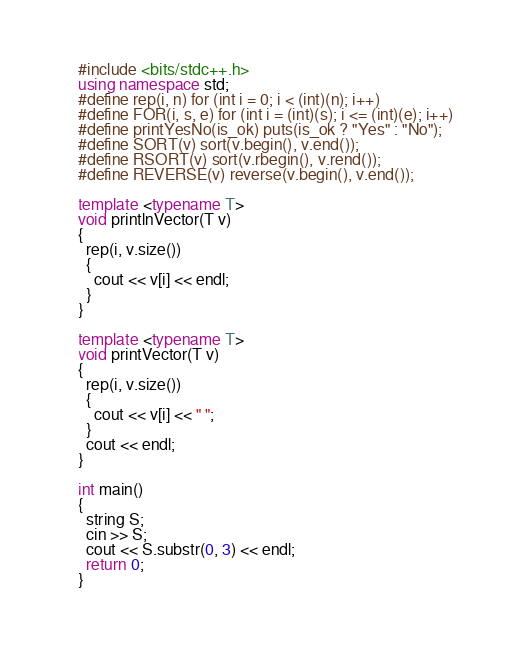Convert code to text. <code><loc_0><loc_0><loc_500><loc_500><_C++_>#include <bits/stdc++.h>
using namespace std;
#define rep(i, n) for (int i = 0; i < (int)(n); i++)
#define FOR(i, s, e) for (int i = (int)(s); i <= (int)(e); i++)
#define printYesNo(is_ok) puts(is_ok ? "Yes" : "No");
#define SORT(v) sort(v.begin(), v.end());
#define RSORT(v) sort(v.rbegin(), v.rend());
#define REVERSE(v) reverse(v.begin(), v.end());

template <typename T>
void printlnVector(T v)
{
  rep(i, v.size())
  {
    cout << v[i] << endl;
  }
}

template <typename T>
void printVector(T v)
{
  rep(i, v.size())
  {
    cout << v[i] << " ";
  }
  cout << endl;
}

int main()
{
  string S;
  cin >> S;
  cout << S.substr(0, 3) << endl;
  return 0;
}</code> 